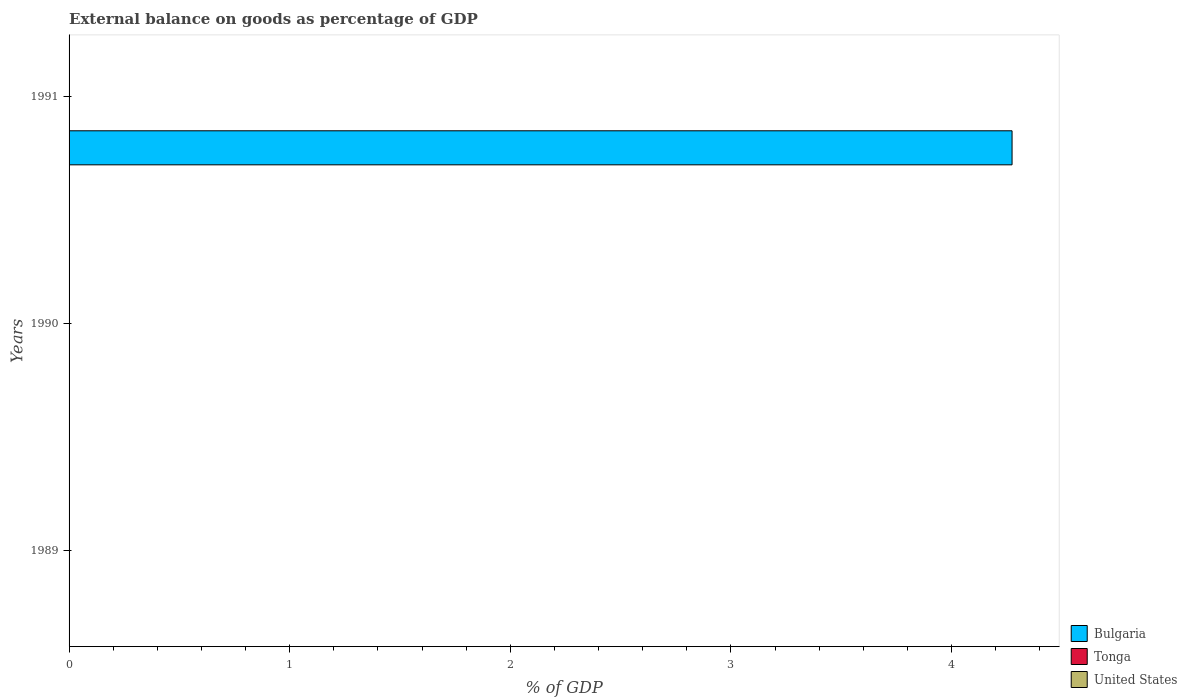How many different coloured bars are there?
Your answer should be very brief. 1. Are the number of bars per tick equal to the number of legend labels?
Your answer should be compact. No. Are the number of bars on each tick of the Y-axis equal?
Your answer should be very brief. No. How many bars are there on the 1st tick from the top?
Provide a succinct answer. 1. What is the label of the 1st group of bars from the top?
Ensure brevity in your answer.  1991. In how many cases, is the number of bars for a given year not equal to the number of legend labels?
Keep it short and to the point. 3. Across all years, what is the minimum external balance on goods as percentage of GDP in Tonga?
Your answer should be compact. 0. What is the difference between the external balance on goods as percentage of GDP in Tonga in 1990 and the external balance on goods as percentage of GDP in United States in 1991?
Your answer should be compact. 0. What is the difference between the highest and the lowest external balance on goods as percentage of GDP in Bulgaria?
Make the answer very short. 4.27. In how many years, is the external balance on goods as percentage of GDP in Tonga greater than the average external balance on goods as percentage of GDP in Tonga taken over all years?
Your answer should be very brief. 0. Are all the bars in the graph horizontal?
Make the answer very short. Yes. What is the difference between two consecutive major ticks on the X-axis?
Offer a very short reply. 1. Where does the legend appear in the graph?
Offer a terse response. Bottom right. How are the legend labels stacked?
Give a very brief answer. Vertical. What is the title of the graph?
Keep it short and to the point. External balance on goods as percentage of GDP. What is the label or title of the X-axis?
Your answer should be compact. % of GDP. What is the % of GDP of Bulgaria in 1989?
Keep it short and to the point. 0. What is the % of GDP in Tonga in 1989?
Keep it short and to the point. 0. What is the % of GDP in Tonga in 1990?
Your answer should be compact. 0. What is the % of GDP of United States in 1990?
Your answer should be compact. 0. What is the % of GDP in Bulgaria in 1991?
Make the answer very short. 4.27. What is the % of GDP of Tonga in 1991?
Offer a very short reply. 0. Across all years, what is the maximum % of GDP of Bulgaria?
Your response must be concise. 4.27. Across all years, what is the minimum % of GDP in Bulgaria?
Offer a terse response. 0. What is the total % of GDP in Bulgaria in the graph?
Keep it short and to the point. 4.27. What is the average % of GDP of Bulgaria per year?
Your answer should be very brief. 1.42. What is the average % of GDP in Tonga per year?
Your response must be concise. 0. What is the difference between the highest and the lowest % of GDP in Bulgaria?
Your answer should be very brief. 4.27. 